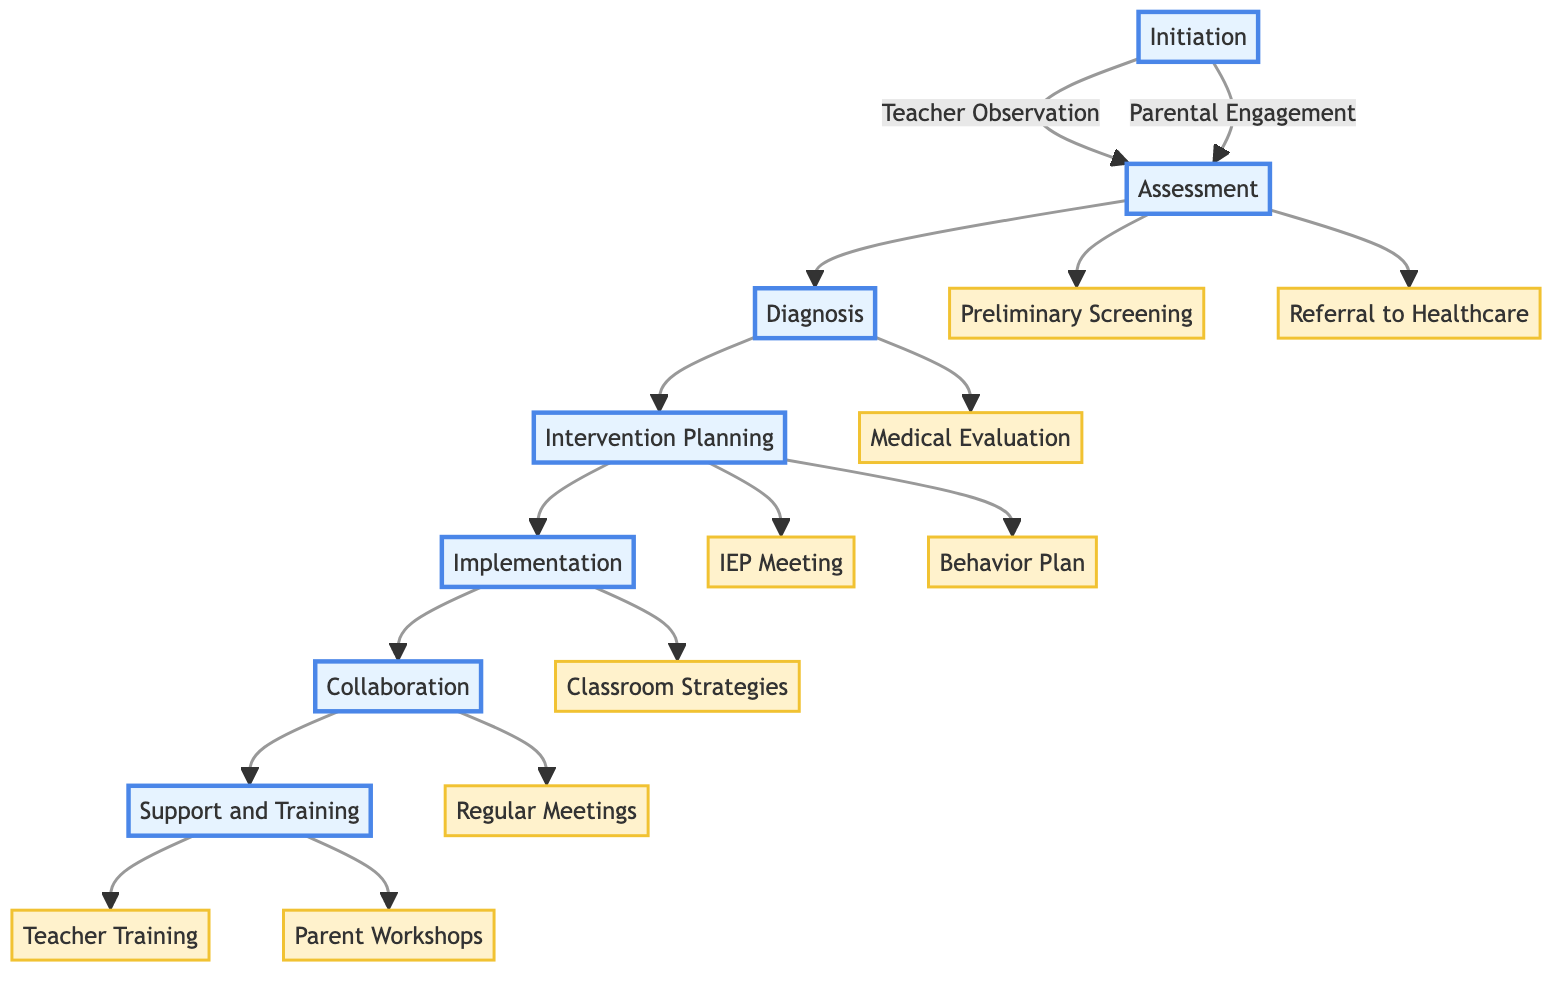What is the first step in the Clinical Pathway? The first step is labeled "Initiation" in the diagram. It sets the stage for the subsequent processes.
Answer: Initiation How many main phases are there in the Clinical Pathway? By counting the phases from Initiation to Support and Training, we identify there are seven main phases in total.
Answer: Seven What does the "Assessment" phase include? The "Assessment" phase includes two actions: "Preliminary Screening" and "Referral to Healthcare." Each represents a critical part of assessing the child's needs.
Answer: Preliminary Screening, Referral to Healthcare Who performs the "Preliminary Screening"? In the diagram, it is specified that the "Preliminary Screening" is performed by the "School Counselor or School Nurse." This directly identifies the personnel involved.
Answer: School Counselor or School Nurse What is the next step after the "Diagnosis" phase? The diagram shows that the next step after "Diagnosis" is "Intervention Planning," which involves strategies tailored for the child's education and behavior management.
Answer: Intervention Planning How are "Teacher Training" and "Parent Workshops" categorized? Both "Teacher Training" and "Parent Workshops" are grouped under the "Support and Training" phase, indicating they provide necessary resources to aid both teachers and parents.
Answer: Support and Training What action follows "Regular Monitoring" in the "Implementation" phase? The diagram does not specify another action after "Regular Monitoring," indicating that it emphasizes ongoing progress tracking within that phase.
Answer: None Which professionals are involved in the "Referral to Healthcare" action? The "Referral to Healthcare" action identifies three types of professionals: "Pediatrician," "Child Psychiatrist," and "Clinical Child Psychologist," showcasing the variety of specialists considered.
Answer: Pediatrician, Child Psychiatrist, Clinical Child Psychologist What signifies the transition from "Implementation" to "Collaboration"? The transition is represented by the arrow leading from "Implementation" to "Collaboration," indicating that following effective implementation, collaboration is necessary to further support the child.
Answer: Collaboration 